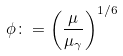Convert formula to latex. <formula><loc_0><loc_0><loc_500><loc_500>\phi \colon = \left ( \frac { \mu } { \mu _ { \gamma } } \right ) ^ { 1 / 6 }</formula> 